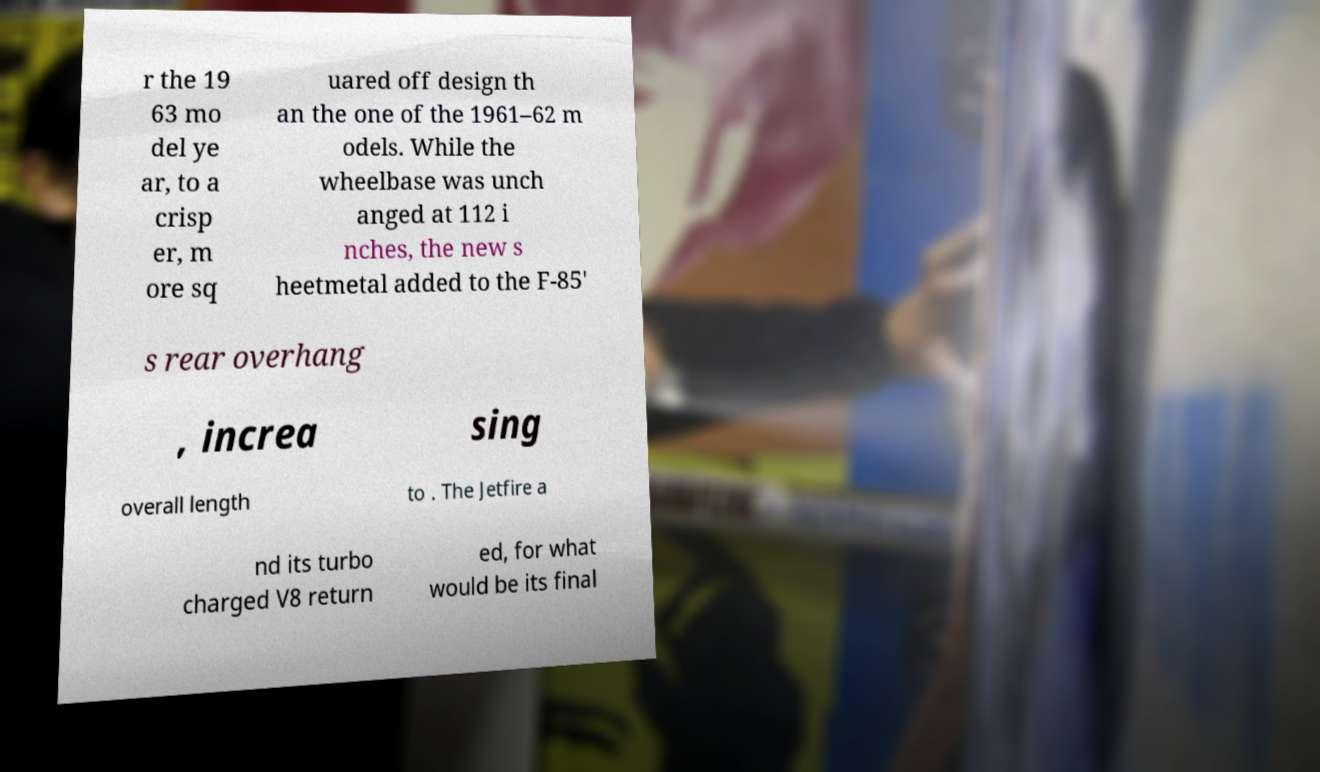Can you read and provide the text displayed in the image?This photo seems to have some interesting text. Can you extract and type it out for me? r the 19 63 mo del ye ar, to a crisp er, m ore sq uared off design th an the one of the 1961–62 m odels. While the wheelbase was unch anged at 112 i nches, the new s heetmetal added to the F-85' s rear overhang , increa sing overall length to . The Jetfire a nd its turbo charged V8 return ed, for what would be its final 